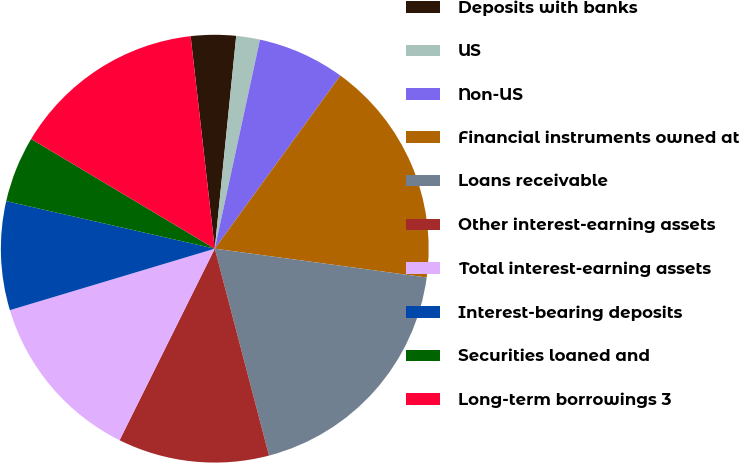Convert chart to OTSL. <chart><loc_0><loc_0><loc_500><loc_500><pie_chart><fcel>Deposits with banks<fcel>US<fcel>Non-US<fcel>Financial instruments owned at<fcel>Loans receivable<fcel>Other interest-earning assets<fcel>Total interest-earning assets<fcel>Interest-bearing deposits<fcel>Securities loaned and<fcel>Long-term borrowings 3<nl><fcel>3.4%<fcel>1.79%<fcel>6.6%<fcel>17.16%<fcel>18.77%<fcel>11.42%<fcel>13.02%<fcel>8.21%<fcel>5.0%<fcel>14.63%<nl></chart> 